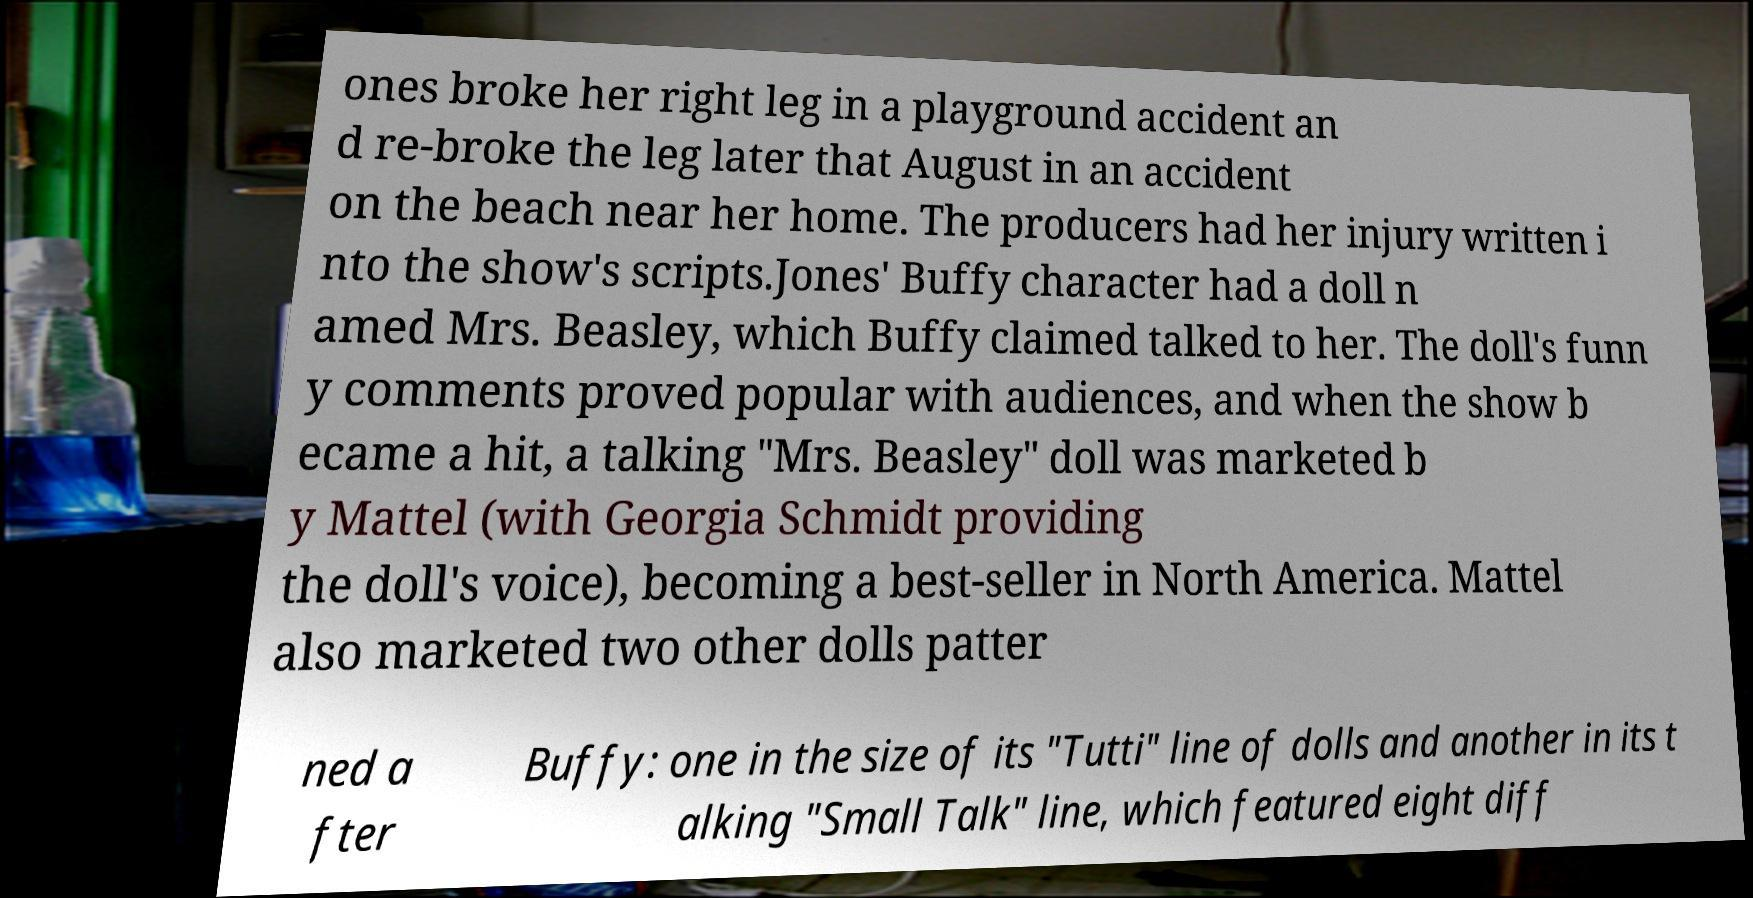I need the written content from this picture converted into text. Can you do that? ones broke her right leg in a playground accident an d re-broke the leg later that August in an accident on the beach near her home. The producers had her injury written i nto the show's scripts.Jones' Buffy character had a doll n amed Mrs. Beasley, which Buffy claimed talked to her. The doll's funn y comments proved popular with audiences, and when the show b ecame a hit, a talking "Mrs. Beasley" doll was marketed b y Mattel (with Georgia Schmidt providing the doll's voice), becoming a best-seller in North America. Mattel also marketed two other dolls patter ned a fter Buffy: one in the size of its "Tutti" line of dolls and another in its t alking "Small Talk" line, which featured eight diff 